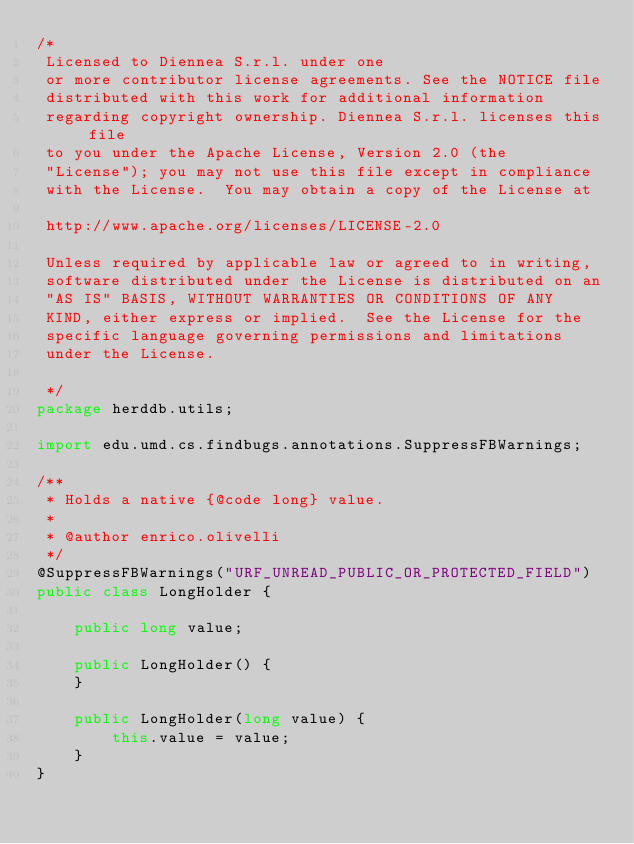Convert code to text. <code><loc_0><loc_0><loc_500><loc_500><_Java_>/*
 Licensed to Diennea S.r.l. under one
 or more contributor license agreements. See the NOTICE file
 distributed with this work for additional information
 regarding copyright ownership. Diennea S.r.l. licenses this file
 to you under the Apache License, Version 2.0 (the
 "License"); you may not use this file except in compliance
 with the License.  You may obtain a copy of the License at

 http://www.apache.org/licenses/LICENSE-2.0

 Unless required by applicable law or agreed to in writing,
 software distributed under the License is distributed on an
 "AS IS" BASIS, WITHOUT WARRANTIES OR CONDITIONS OF ANY
 KIND, either express or implied.  See the License for the
 specific language governing permissions and limitations
 under the License.

 */
package herddb.utils;

import edu.umd.cs.findbugs.annotations.SuppressFBWarnings;

/**
 * Holds a native {@code long} value.
 *
 * @author enrico.olivelli
 */
@SuppressFBWarnings("URF_UNREAD_PUBLIC_OR_PROTECTED_FIELD")
public class LongHolder {

    public long value;

    public LongHolder() {
    }

    public LongHolder(long value) {
        this.value = value;
    }
}
</code> 